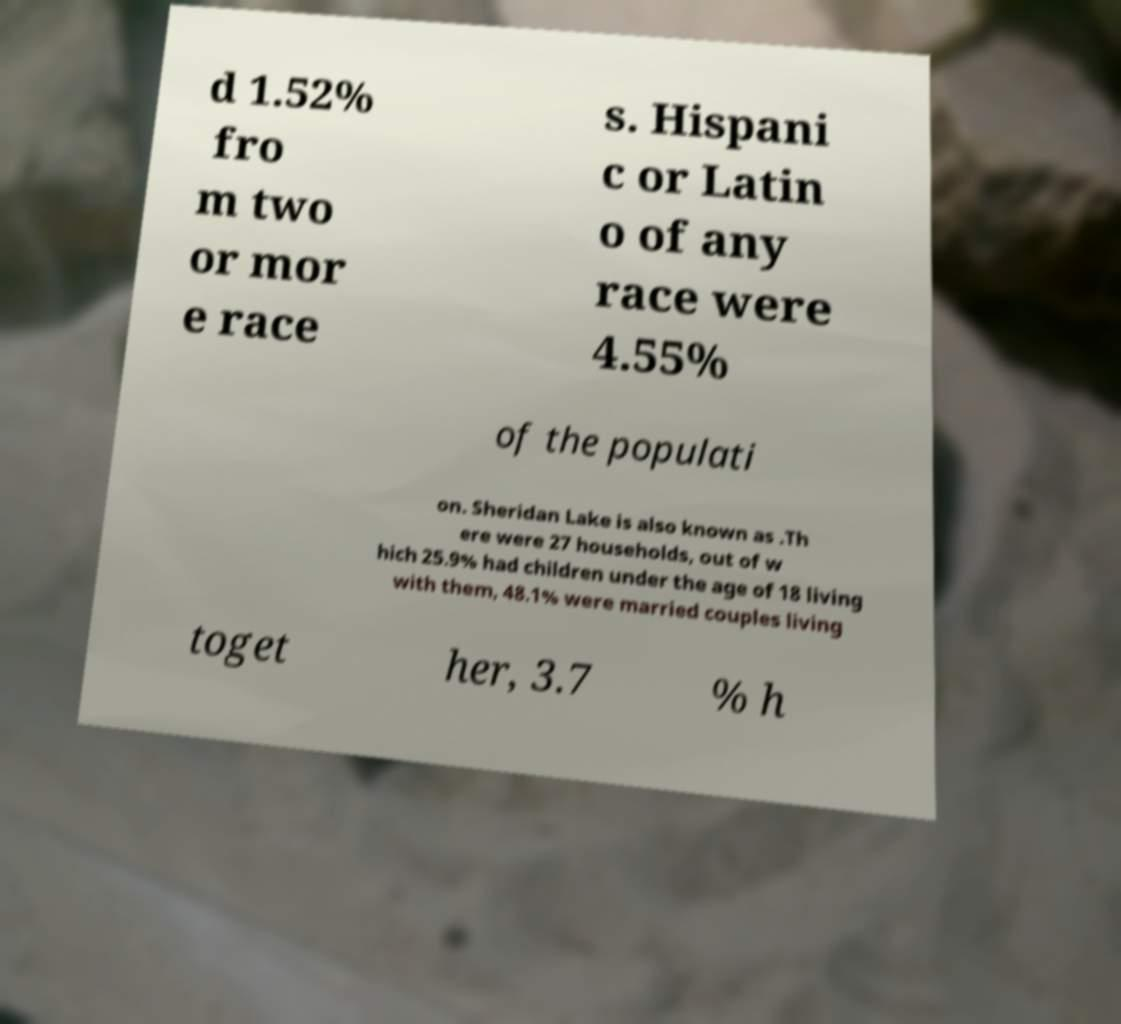Can you accurately transcribe the text from the provided image for me? d 1.52% fro m two or mor e race s. Hispani c or Latin o of any race were 4.55% of the populati on. Sheridan Lake is also known as .Th ere were 27 households, out of w hich 25.9% had children under the age of 18 living with them, 48.1% were married couples living toget her, 3.7 % h 